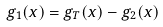Convert formula to latex. <formula><loc_0><loc_0><loc_500><loc_500>g _ { 1 } ( x ) = g _ { T } ( x ) - g _ { 2 } ( x )</formula> 